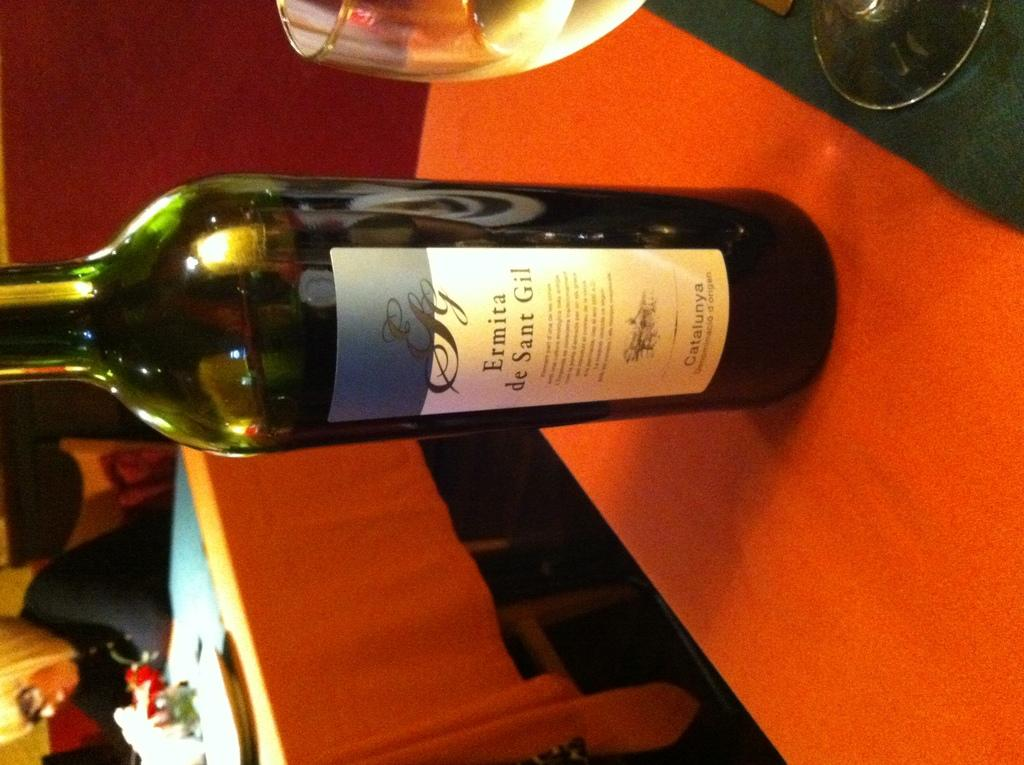What is the main object in the image? There is a wine bottle in the image. What color is the wine bottle? The wine bottle is green in color. Is there any text or design on the wine bottle? Yes, there is a label on the wine bottle. What other object related to wine can be seen in the image? There is a wine glass in the image. Who is the manager of the vineyard where the wine in the bottle was produced? The image does not provide information about the vineyard or its manager, so we cannot answer that question. 